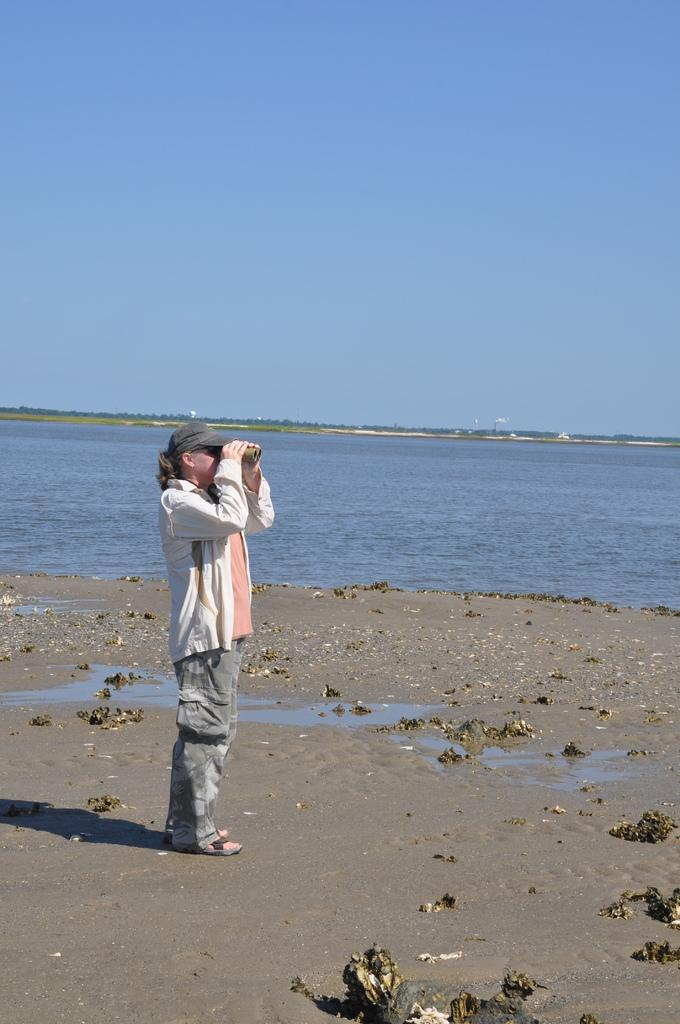What is the person in the image doing? The person is standing in the image and holding binoculars. What might the person be observing with the binoculars? The person might be observing the water flowing in the image or the sky visible in the image. What type of clothing is the person wearing? The person is wearing a cap, a jerkin, trousers, and sandals. What direction is the person biting in the image? There is no indication that the person is biting anything in the image. The person is holding binoculars and standing, not biting. 